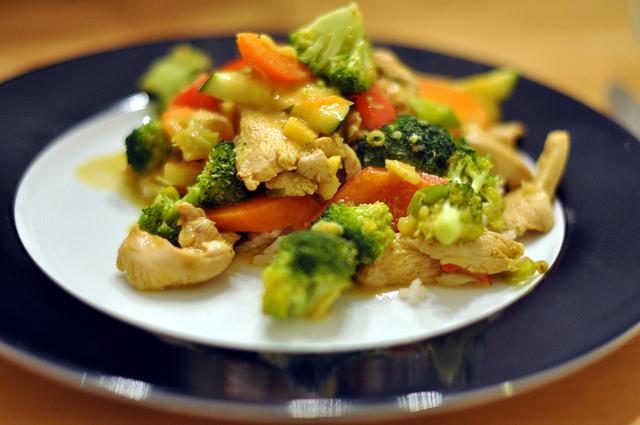What two vegetables are present?
Short answer required. Broccoli and carrots. What color is the plate?
Quick response, please. White. Is the meat chicken?
Answer briefly. Yes. 